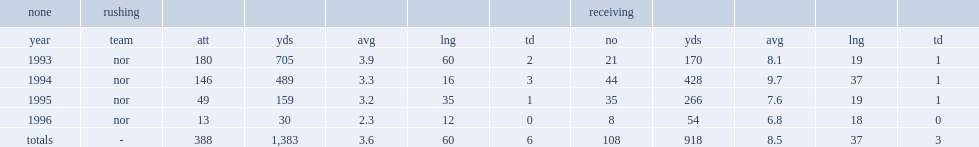How many rushing yards did derek brown get totally? 1383.0. 